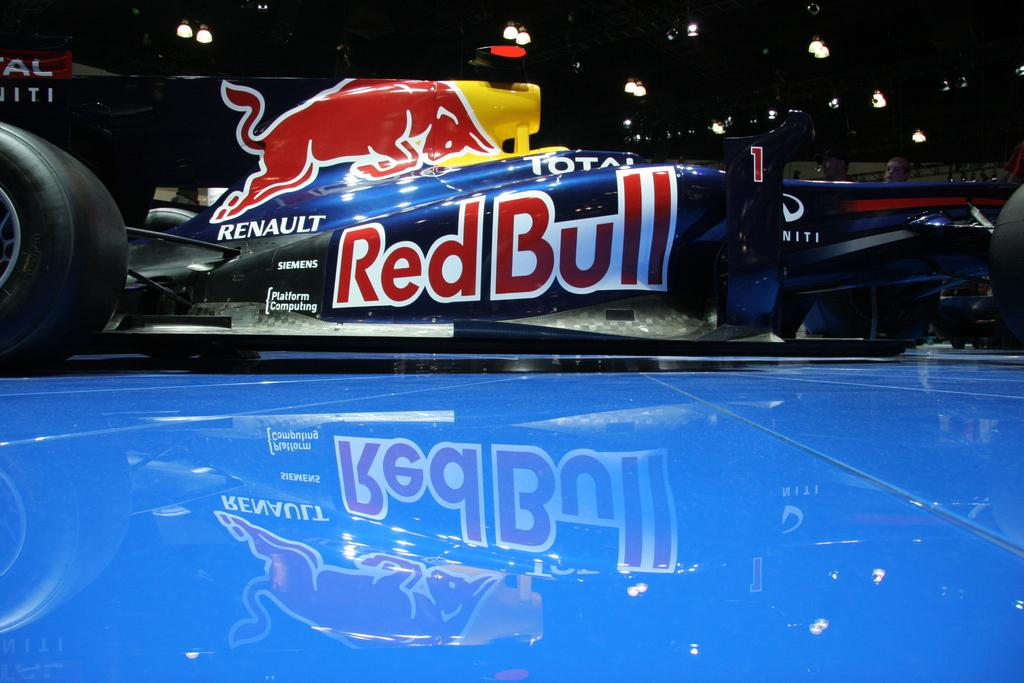What is the main subject of the picture? The main subject of the picture is a go kart. What color is the surface in the foreground of the image? The surface in the foreground of the image is blue. What can be seen on the ceiling in the picture? There are lights on the ceiling in the picture. What level of education is required to use the go kart in the image? The image does not provide any information about the level of education required to use the go kart, as it is not relevant to the image itself. 